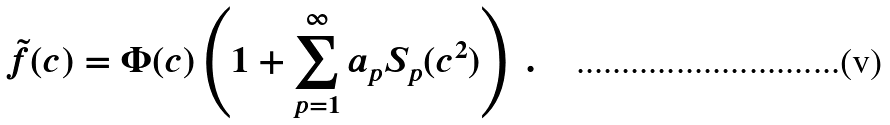Convert formula to latex. <formula><loc_0><loc_0><loc_500><loc_500>\tilde { f } ( c ) = \Phi ( c ) \left ( 1 + \sum _ { p = 1 } ^ { \infty } a _ { p } S _ { p } ( c ^ { 2 } ) \right ) \ .</formula> 